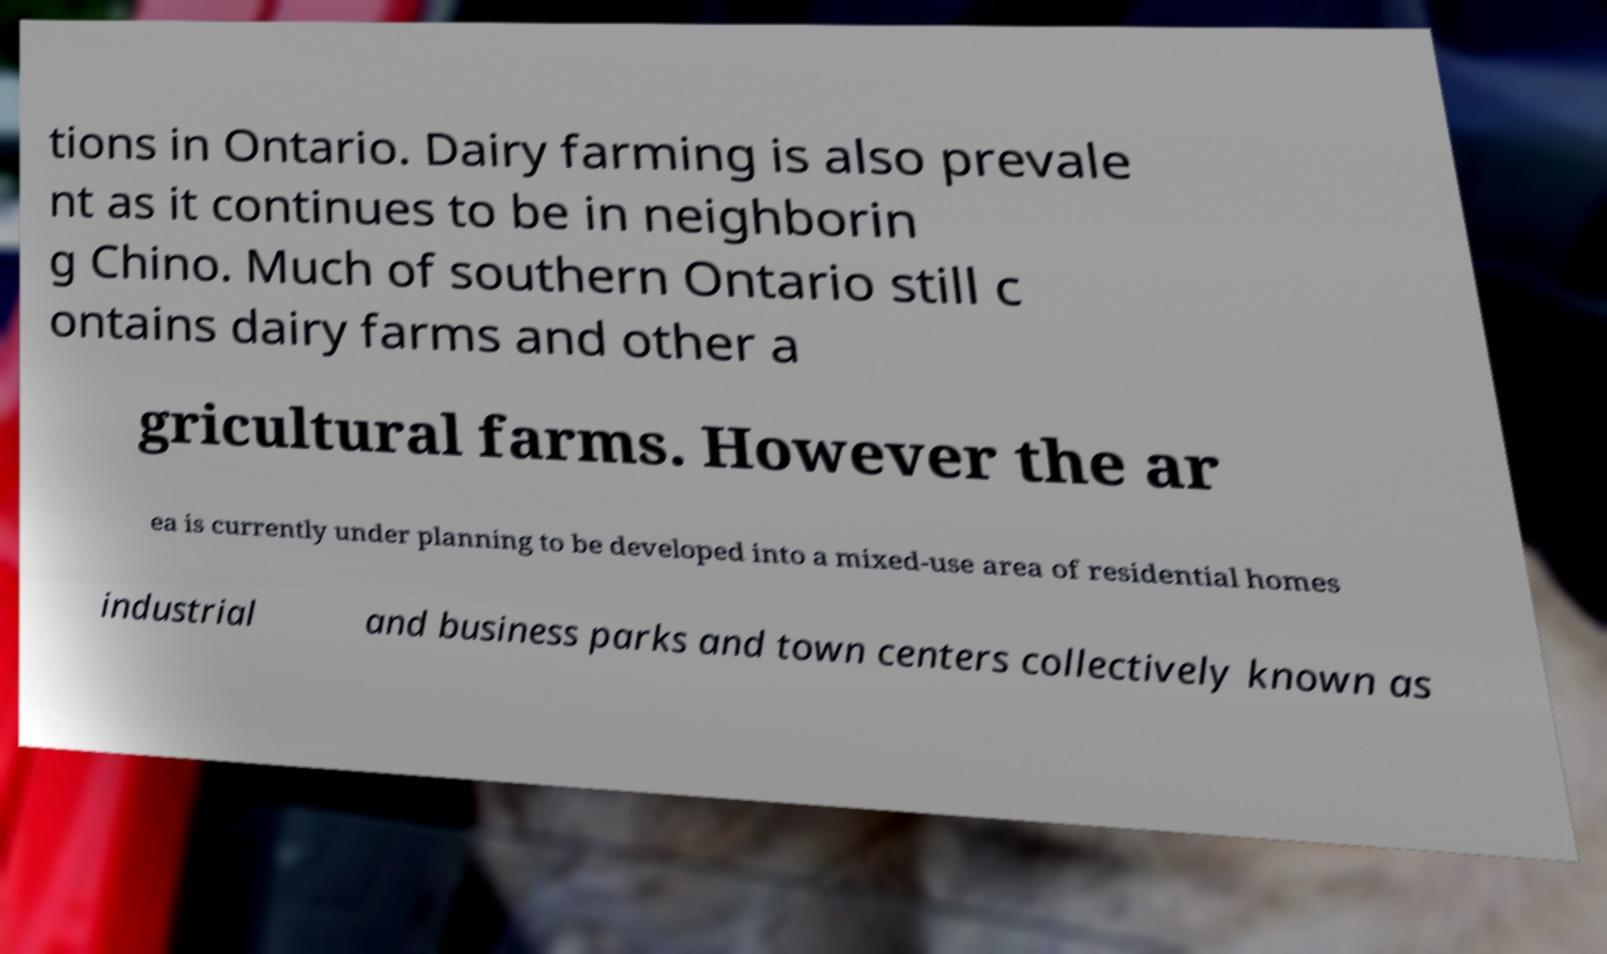Could you assist in decoding the text presented in this image and type it out clearly? tions in Ontario. Dairy farming is also prevale nt as it continues to be in neighborin g Chino. Much of southern Ontario still c ontains dairy farms and other a gricultural farms. However the ar ea is currently under planning to be developed into a mixed-use area of residential homes industrial and business parks and town centers collectively known as 